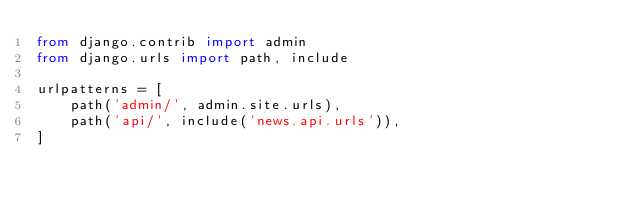Convert code to text. <code><loc_0><loc_0><loc_500><loc_500><_Python_>from django.contrib import admin
from django.urls import path, include

urlpatterns = [
    path('admin/', admin.site.urls),
    path('api/', include('news.api.urls')),
]
</code> 